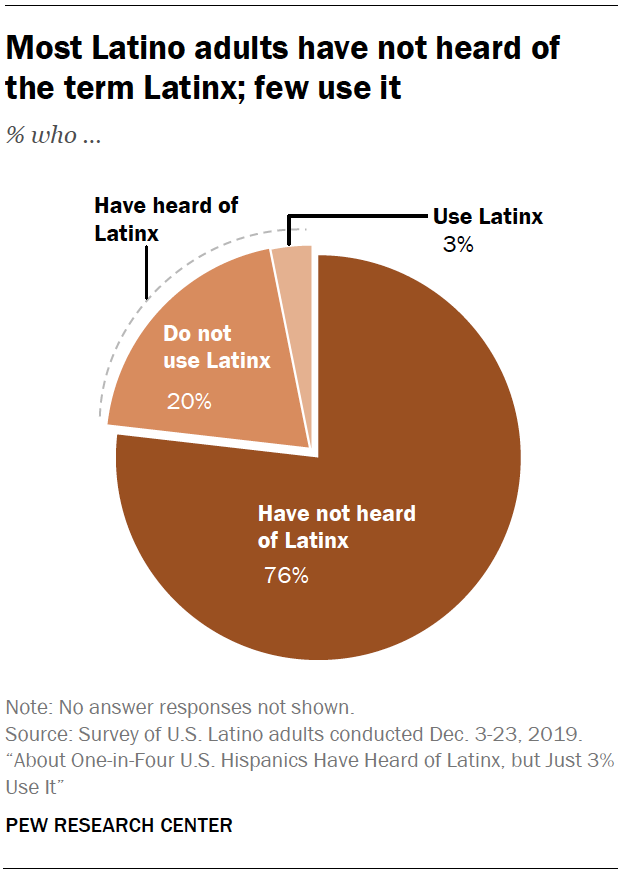What does the pie chart indicate about the usage of the term 'Latinx'? The pie chart shows that a small portion of Latino adults, specifically 3%, use the term 'Latinx'. The majority, 76%, have not heard of the term, and 20% have heard of it but do not use it. 